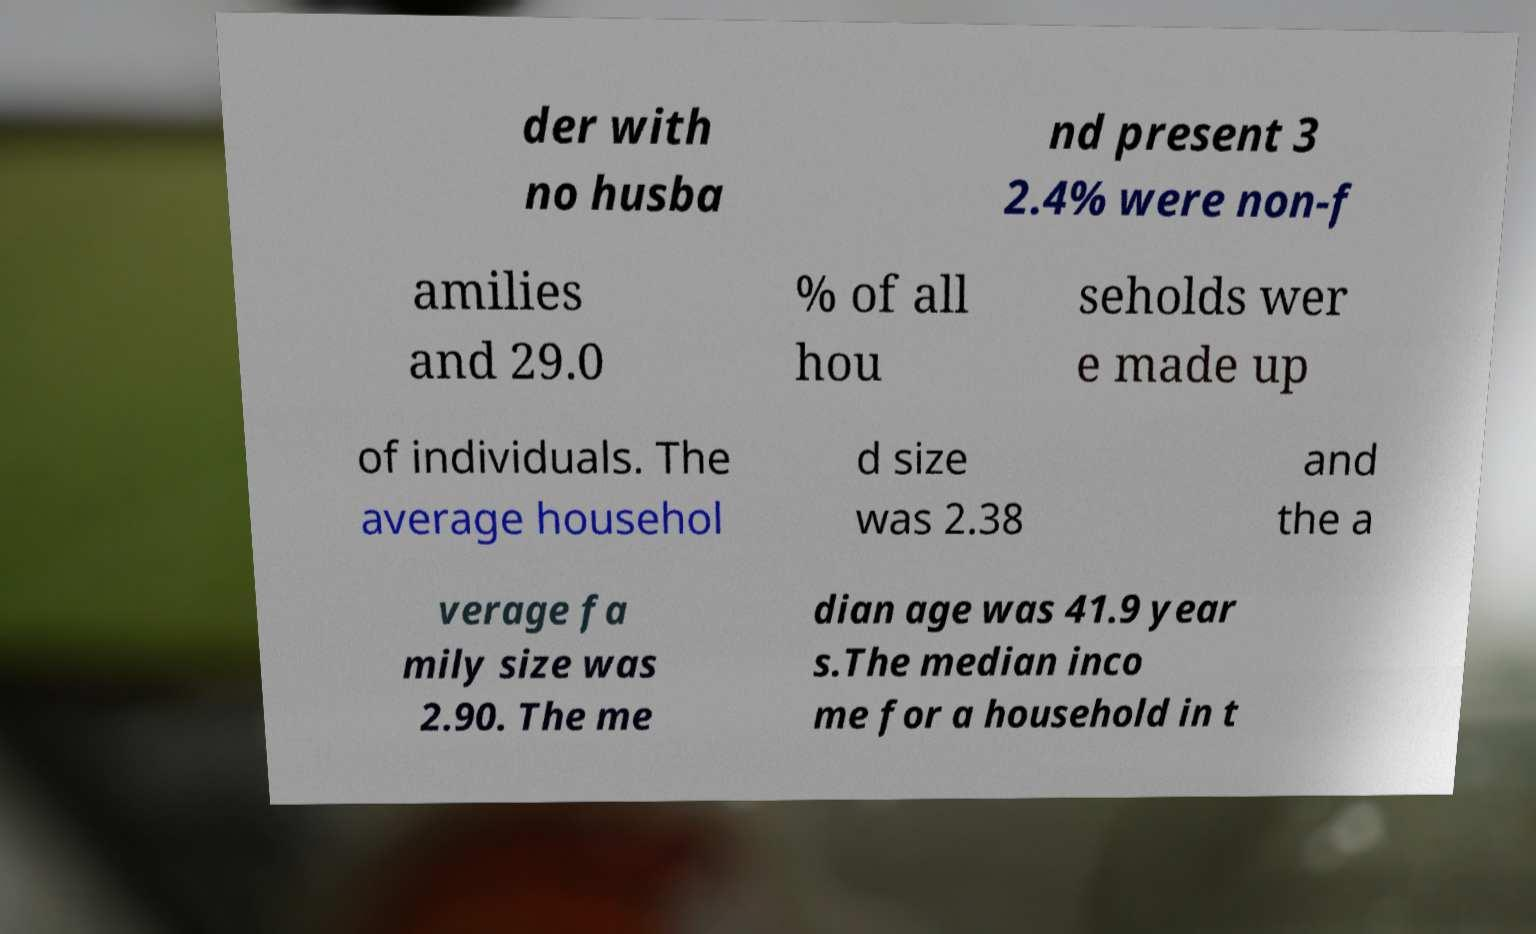Can you accurately transcribe the text from the provided image for me? der with no husba nd present 3 2.4% were non-f amilies and 29.0 % of all hou seholds wer e made up of individuals. The average househol d size was 2.38 and the a verage fa mily size was 2.90. The me dian age was 41.9 year s.The median inco me for a household in t 